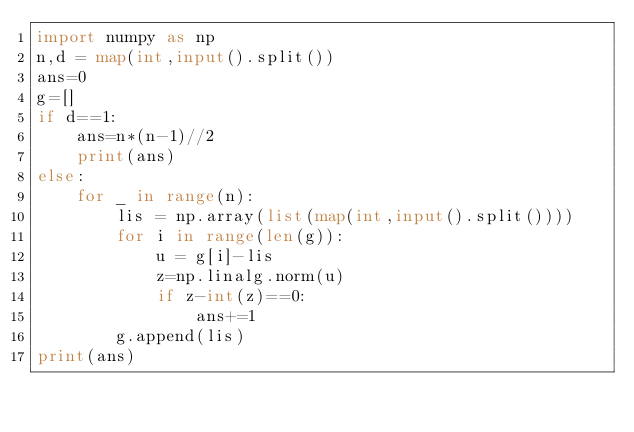Convert code to text. <code><loc_0><loc_0><loc_500><loc_500><_Python_>import numpy as np
n,d = map(int,input().split())
ans=0
g=[]
if d==1:
    ans=n*(n-1)//2
    print(ans)
else:
    for _ in range(n):
        lis = np.array(list(map(int,input().split())))
        for i in range(len(g)):
            u = g[i]-lis
            z=np.linalg.norm(u)
            if z-int(z)==0:
                ans+=1
        g.append(lis)
print(ans)</code> 